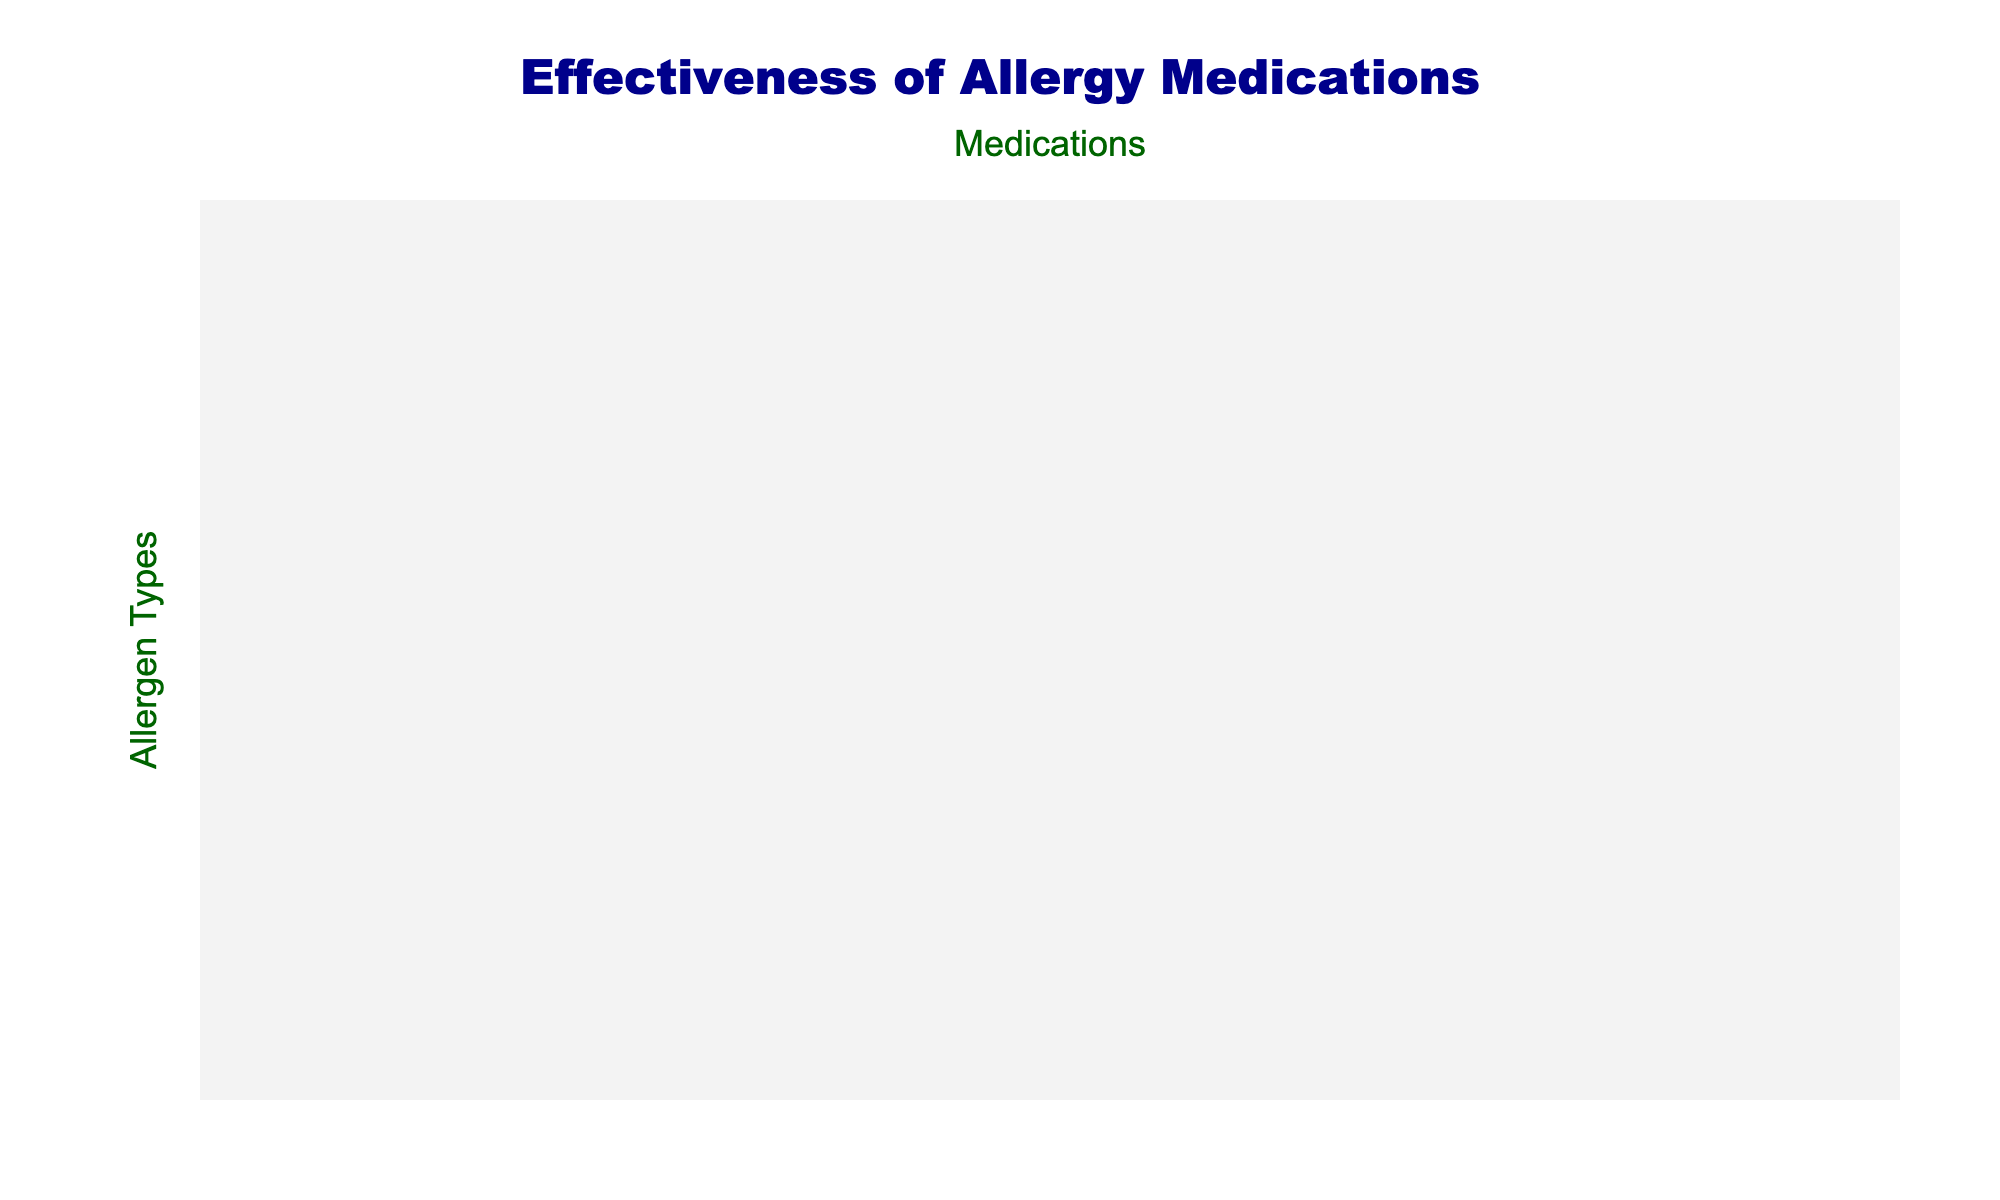What is the highest effectiveness rate among the medications for pollen? Referring to the table, the effectiveness rates for pollen are 85% for Cetirizine, 80% for Loratadine, 82% for Fexofenadine, 78% for Desloratadine, and 88% for Levocetirizine. The highest value is 88%.
Answer: 88% Which medication has the lowest effectiveness for dust mite allergies? In the column for Dust Mites, the effectiveness rates are 75% for Cetirizine, 72% for Loratadine, 78% for Fexofenadine, 76% for Desloratadine, and 80% for Levocetirizine. The lowest value is 72%.
Answer: 72% Does Levocetirizine have a better effectiveness rate for pet dander compared to Fexofenadine? The effectiveness for Pet Dander is 75% for Levocetirizine and 73% for Fexofenadine. Since 75% is greater than 73%, Levocetirizine is more effective.
Answer: Yes What is the average effectiveness of all medications for mold spores? The effectiveness rates for mold spores are 65%, 62%, 68%, 64%, and 70%. Adding these gives 65 + 62 + 68 + 64 + 70 = 329. Dividing by 5 (the number of medications) gives an average of 65.8%.
Answer: 65.8% Which allergen has the lowest overall medication effectiveness when averaged? The effectiveness rates for Food Allergies are 60%, 58%, 63%, 59%, and 65%. Summing these gives 60 + 58 + 63 + 59 + 65 = 305. The average is 305/5 = 61%. Comparing with other allergens reveals that this is the lowest average.
Answer: Food Allergies Is there any allergen type for which all medications have an effectiveness rate above 70%? Checking the rates, Pollen and Dust Mites have all medications above 70%, while Pet Dander, Mold Spores, Food Allergies, Insect Stings, and Latex have at least one medication below 70%. Thus, only Pollen and Dust Mites meet the criteria.
Answer: Yes What is the difference in effectiveness between Cetirizine and Loratadine for insect sting allergies? Cetirizine has an effectiveness of 55% and Loratadine 52%. The difference is 55% - 52% = 3%.
Answer: 3% Which medication is most consistently effective across all allergen types? By observing the effectiveness rates across all allergens, Levocetirizine mostly scores the highest effectiveness among the different allergens, and its lowest score (55% on Latex) is also higher compared to others’ scores on various allergens.
Answer: Levocetirizine 